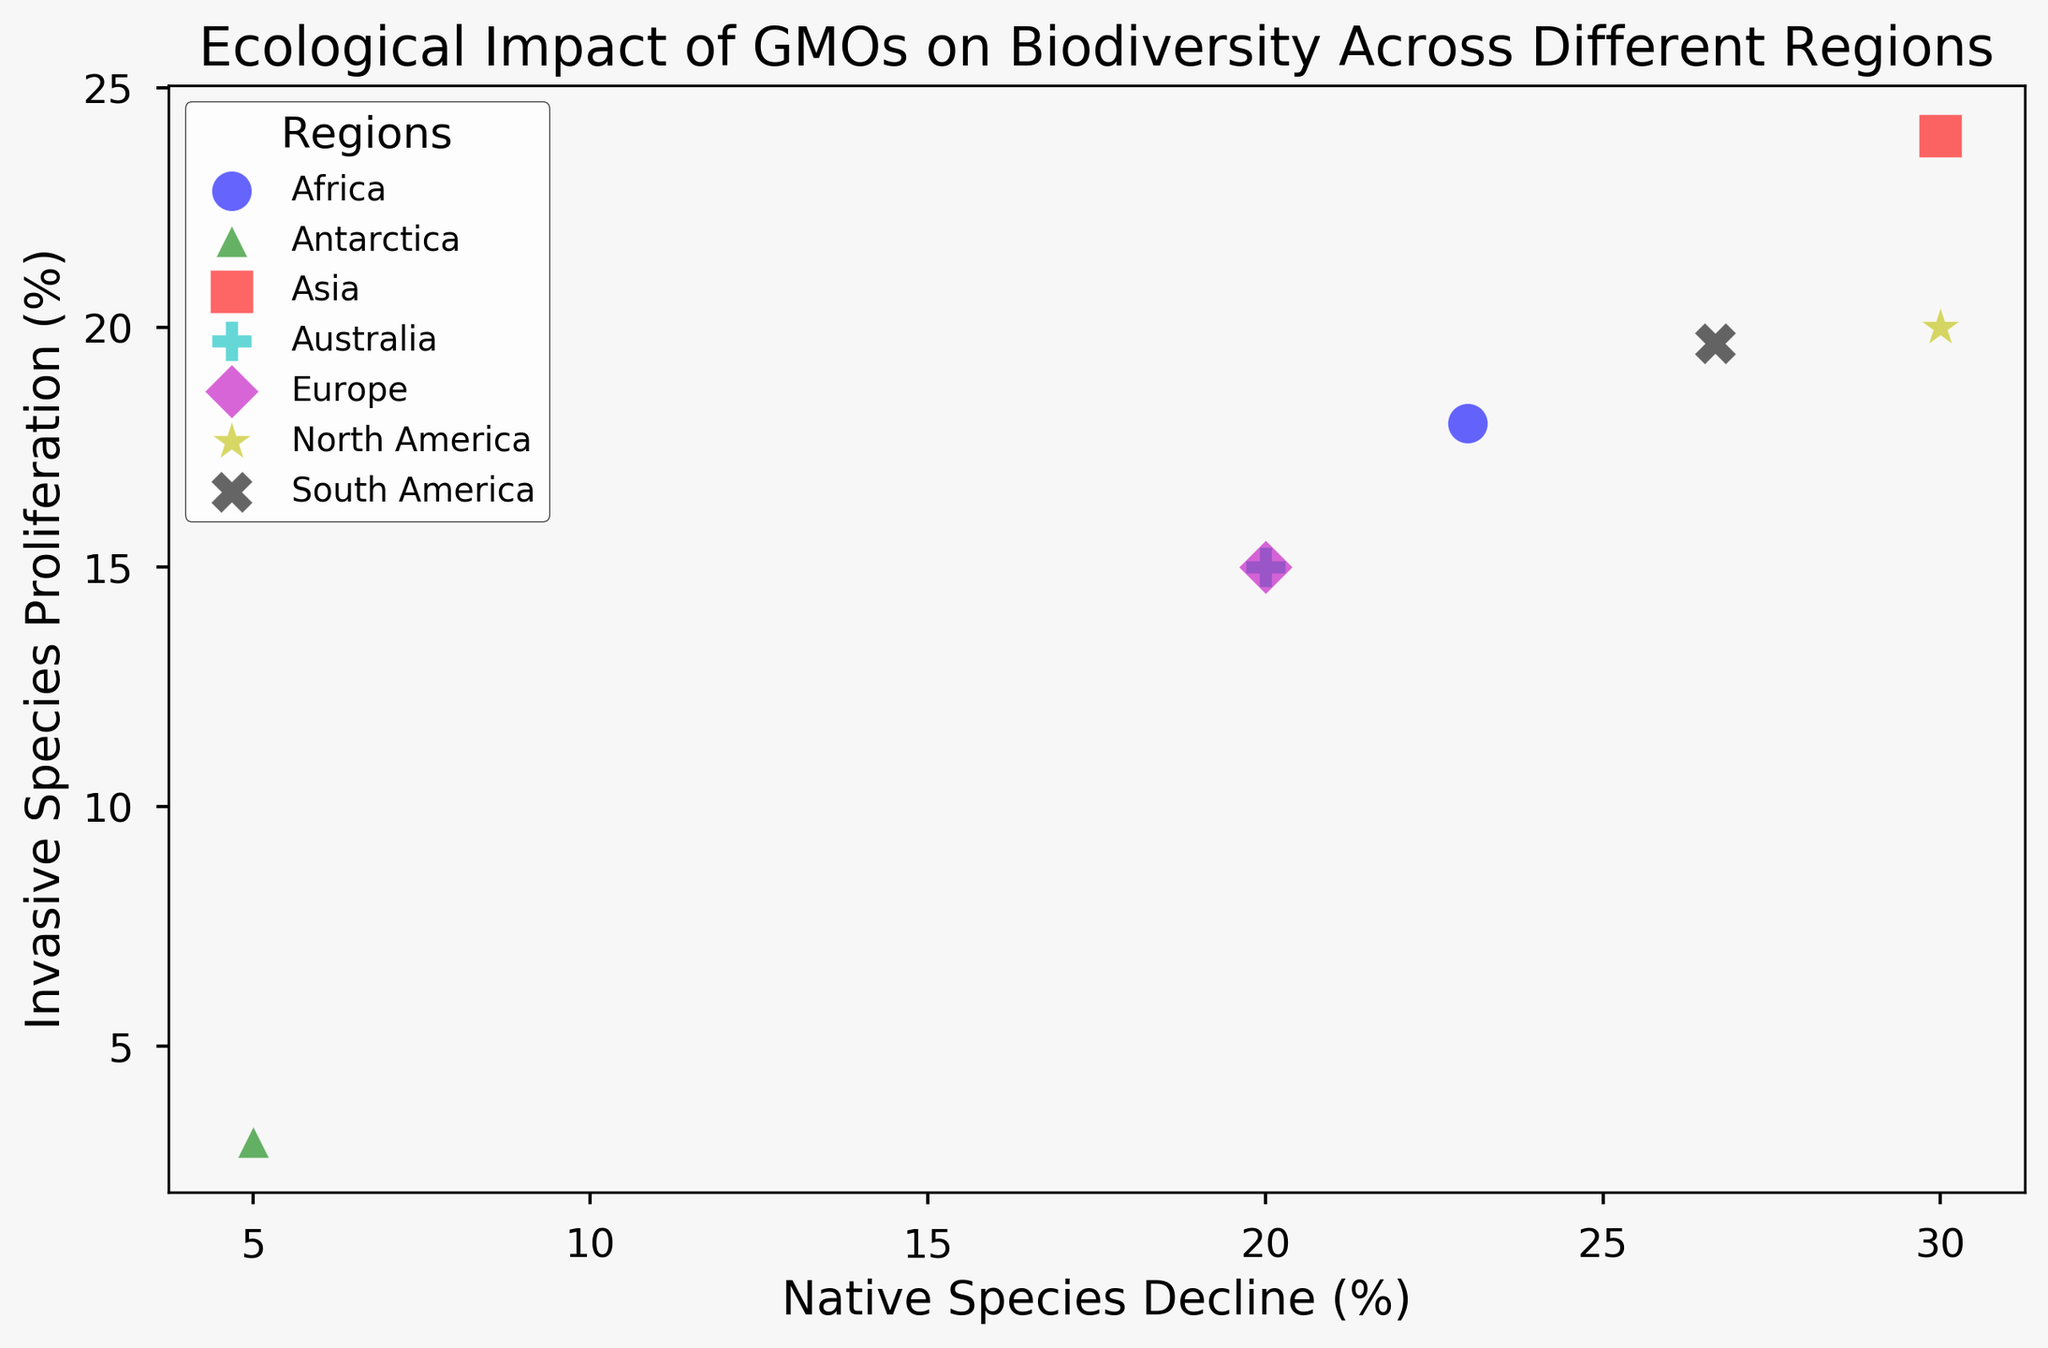What region shows the highest Invasive Species Proliferation? The visual attributes of the markers show that the region with the highest Invasive Species Proliferation is the one situated the furthest along the y-axis (uppermost point).
Answer: Asia Which region has the lowest Ecological Disturbance Index? The marker size indicates the Ecological Disturbance Index. The smallest marker represents the lowest index. The smallest marker is for Antarctica.
Answer: Antarctica Between North America and South America, which region has a higher Native Species Decline? Both regions' markers need to be compared on the x-axis. The marker for South America is further along the x-axis, indicating a higher Native Species Decline.
Answer: South America Which region has the highest combination of Ecological Disturbance Index and Invasive Species Proliferation? First identify the largest marker, indicating the highest Ecological Disturbance Index, and ensure it is positioned highest vertically (y-axis) for Invasive Species Proliferation. Asia's marker, which is the largest and highest vertically, meets both criteria.
Answer: Asia What is the difference in Native Species Decline between Europe and Africa? The x-axis positions need to be observed for Europe and Africa. The Native Species Decline for Europe is about 20%, while for Africa, it's around 23%. So, 23% - 20% = 3%.
Answer: 3% Which region has the closest balance between Native Species Decline and Invasive Species Proliferation? The region whose marker is closer to a diagonal line from the origin (where x equals y) indicates a balance. Africa’s marker lies closer to such a balance, with both values nearly the same.
Answer: Africa How does the Ecological Disturbance Index in Asia compare to that in Europe? Comparing the sizes of the markers for Asia and Europe, Asia has a larger marker, indicating a higher Ecological Disturbance Index.
Answer: Asia Which region appears the most disturbed ecologically according to the size of the markers? The largest marker signifies the highest Ecological Disturbance Index. Asia’s marker is the largest.
Answer: Asia Which two regions have the highest disparity in Invasive Species Proliferation? The positions along the y-axis need to be noted. Asia (highest) and Antarctica (lowest) show the greatest difference in Invasive Species Proliferation.
Answer: Asia and Antarctica 